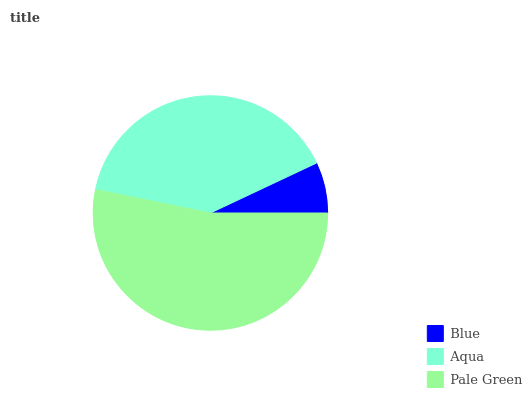Is Blue the minimum?
Answer yes or no. Yes. Is Pale Green the maximum?
Answer yes or no. Yes. Is Aqua the minimum?
Answer yes or no. No. Is Aqua the maximum?
Answer yes or no. No. Is Aqua greater than Blue?
Answer yes or no. Yes. Is Blue less than Aqua?
Answer yes or no. Yes. Is Blue greater than Aqua?
Answer yes or no. No. Is Aqua less than Blue?
Answer yes or no. No. Is Aqua the high median?
Answer yes or no. Yes. Is Aqua the low median?
Answer yes or no. Yes. Is Blue the high median?
Answer yes or no. No. Is Blue the low median?
Answer yes or no. No. 